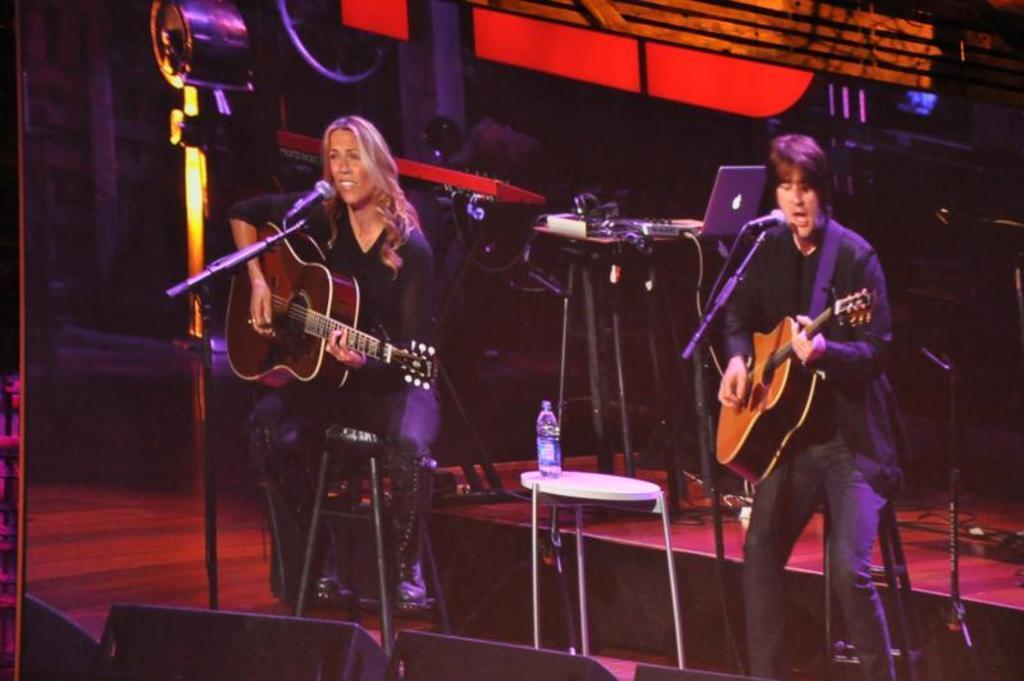Please provide a concise description of this image. In this image I can see two people are in front of the mic and playing the guitar. Between them there is table. On the table there is a water bottle. In the background there is a laptop and some connectors. 